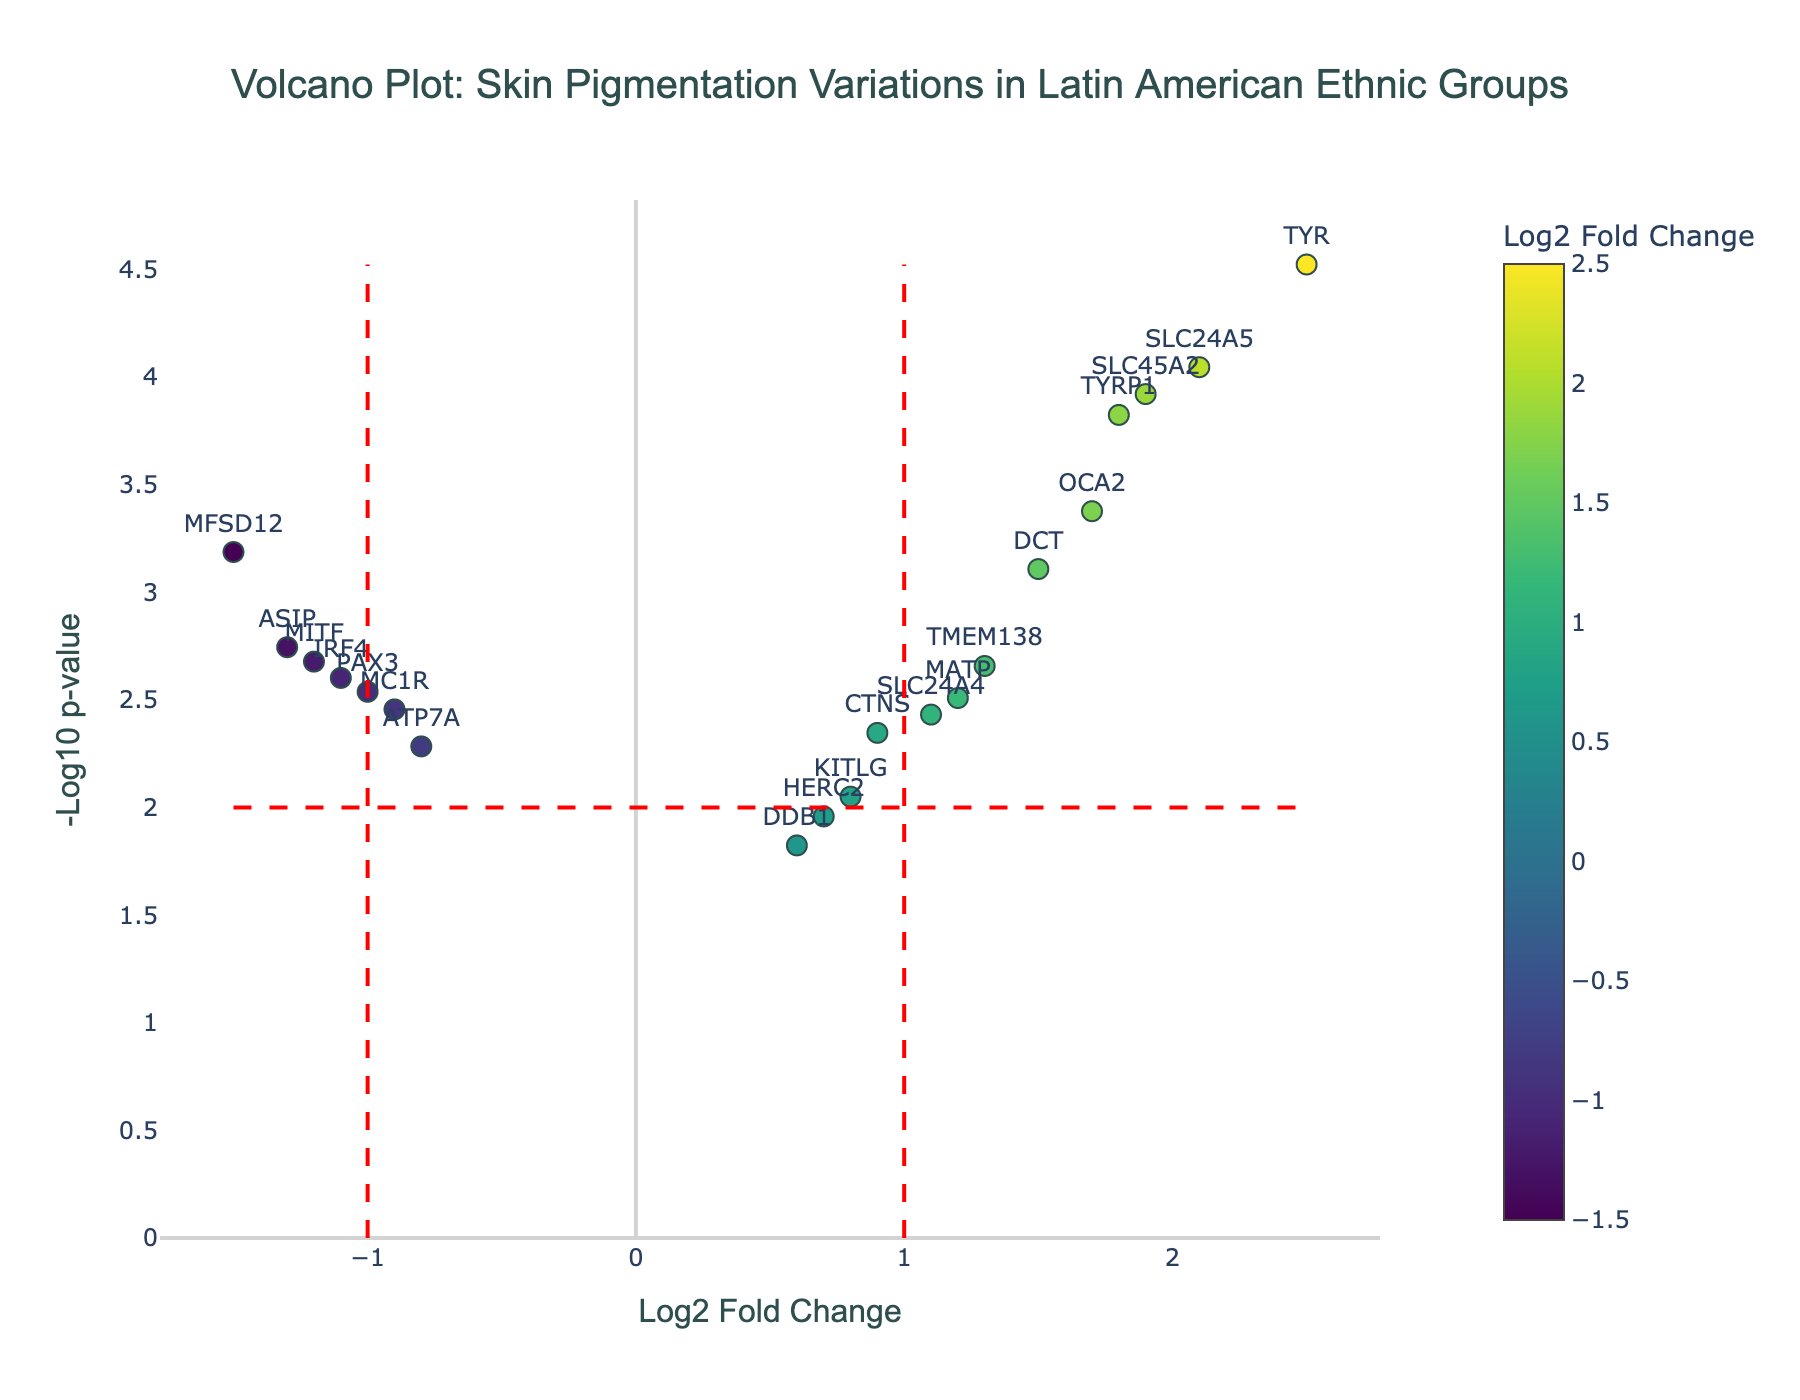What is the title of the plot? The title is displayed at the top center of the plot. It reads: "Volcano Plot: Skin Pigmentation Variations in Latin American Ethnic Groups."
Answer: Volcano Plot: Skin Pigmentation Variations in Latin American Ethnic Groups Which axis represents the p-value? The p-value is visualized on the vertical axis, represented as -log10(p-value).
Answer: Vertical axis How many genes have a log2 fold change greater than 1? Genes with a log2 fold change greater than 1 are represented by points to the right of the vertical line at log2 fold change = 1. The relevant genes are TYR, TYRP1, SLC24A5, OCA2, SLC45A2, and TMEM138. Counting these gives 6 genes.
Answer: 6 Which gene has the highest -log10(p-value)? The -log10(p-value) is highest for the gene with the point at the top-most part of the plot. Here, TYR has the highest -log10(p-value).
Answer: TYR Are there more genes with positive or negative log2 fold changes? Count the points to the right of log2 fold change = 0 (positive) and to the left (negative). There are more genes with positive log2 fold changes.
Answer: Positive What is the gene with the lowest log2 fold change and what is its -log10(p-value)? The gene with the lowest log2 fold change is MFSD12, and its -log10(p-value) can be found by its position vertically, which is approximately 3.19.
Answer: MFSD12, 3.19 Identify a gene with both low log2 fold change (close to 0) and low significance (-log10(p-value) less than 2)? The gene HERC2 fits these conditions, with a log2 fold change of 0.7 and a -log10(p-value) less than 2.
Answer: HERC2 How many genes have -log10(p-value) greater than 2? Genes with a -log10(p-value) greater than 2 are those above the horizontal line at -log10(p-value) = 2. Counting these points gives the total. There are 15 genes.
Answer: 15 Which gene has the largest positive log2 fold change? The gene with the point farthest to the right has the largest positive log2 fold change. This gene is TYR with a log2 fold change of 2.5.
Answer: TYR 